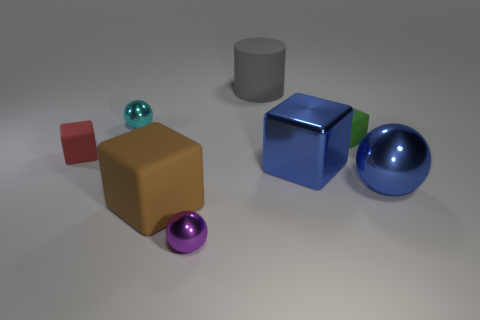Subtract all tiny shiny balls. How many balls are left? 1 Add 2 blue balls. How many objects exist? 10 Subtract 1 cubes. How many cubes are left? 3 Subtract all blue blocks. How many blocks are left? 3 Subtract all cyan cubes. How many cyan spheres are left? 1 Subtract all balls. Subtract all matte objects. How many objects are left? 1 Add 7 small spheres. How many small spheres are left? 9 Add 1 large blue blocks. How many large blue blocks exist? 2 Subtract 0 yellow spheres. How many objects are left? 8 Subtract all spheres. How many objects are left? 5 